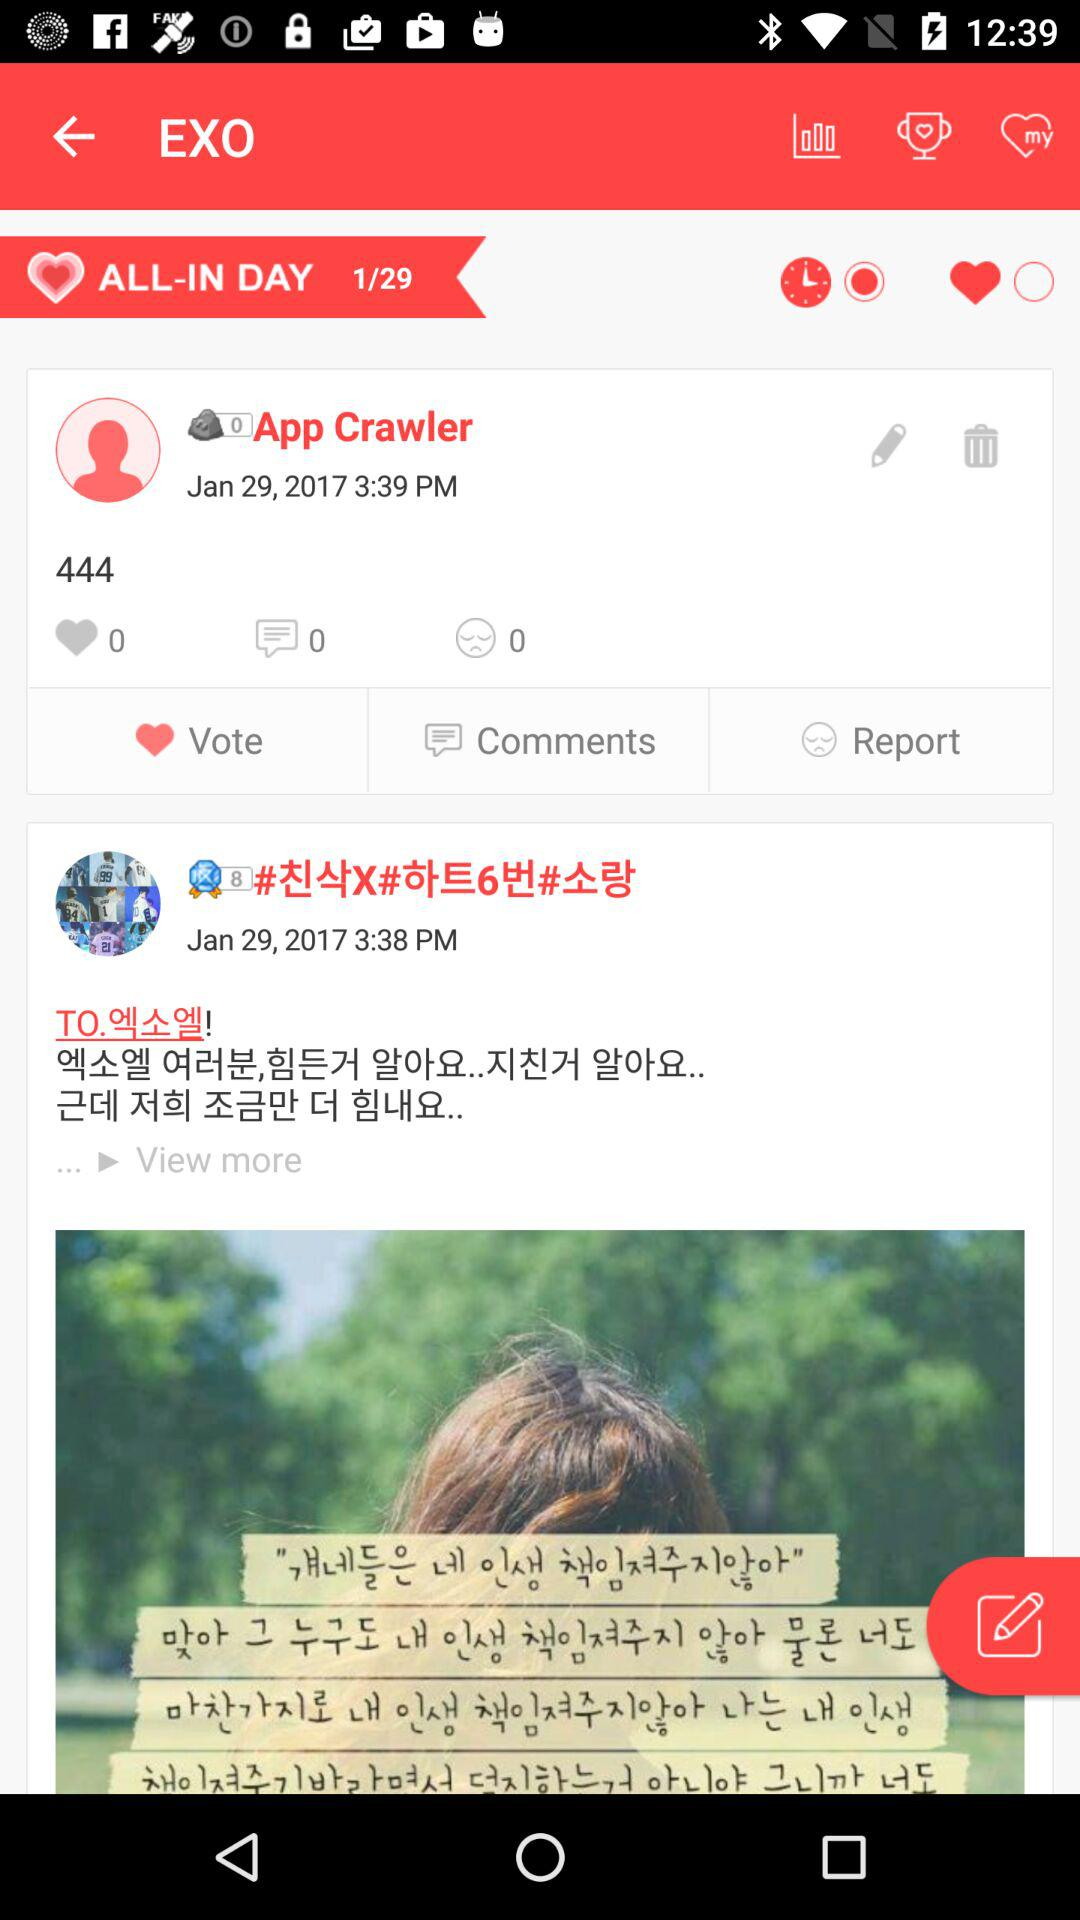At what time did App Crawler post? App Crawler posted at 3:39 p.m. 